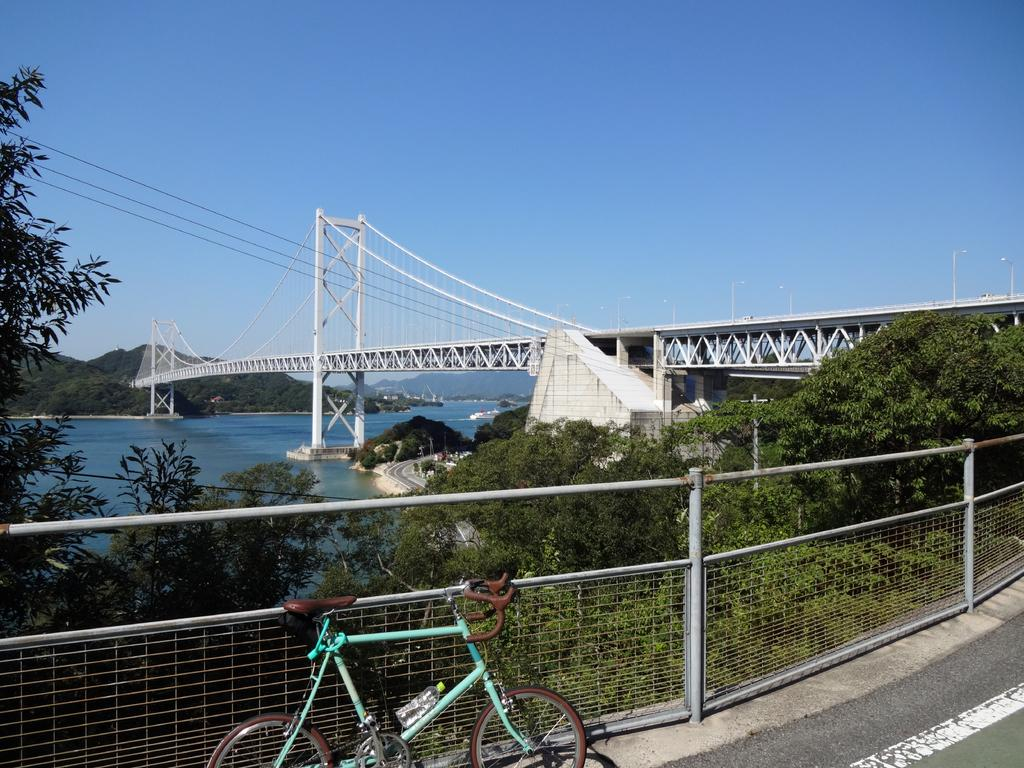What is the main subject of the image? There is a bicycle on the road in the image. What can be seen in the background of the image? There are trees, a bridge, a fence, and hills in the background of the image. What else is visible in the image besides the bicycle and background elements? There is water visible in the image. What is visible at the top of the image? The sky is visible at the top of the image. What unit of measurement is used to determine the distance the bicycle has traveled in the image? There is no information provided about the distance the bicycle has traveled, nor is there any indication of a unit of measurement in the image. 